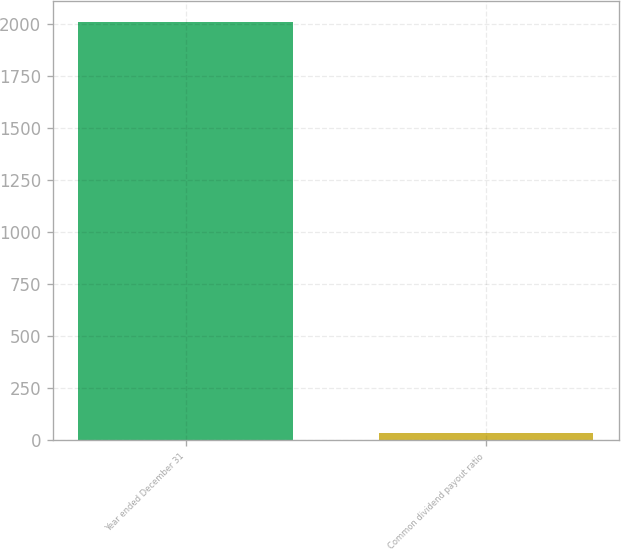Convert chart. <chart><loc_0><loc_0><loc_500><loc_500><bar_chart><fcel>Year ended December 31<fcel>Common dividend payout ratio<nl><fcel>2007<fcel>34<nl></chart> 